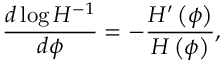<formula> <loc_0><loc_0><loc_500><loc_500>{ \frac { d \log { H ^ { - 1 } } } { d \phi } } = - { \frac { H ^ { \prime } \left ( \phi \right ) } { H \left ( \phi \right ) } } ,</formula> 